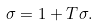Convert formula to latex. <formula><loc_0><loc_0><loc_500><loc_500>\sigma = 1 + T \sigma .</formula> 